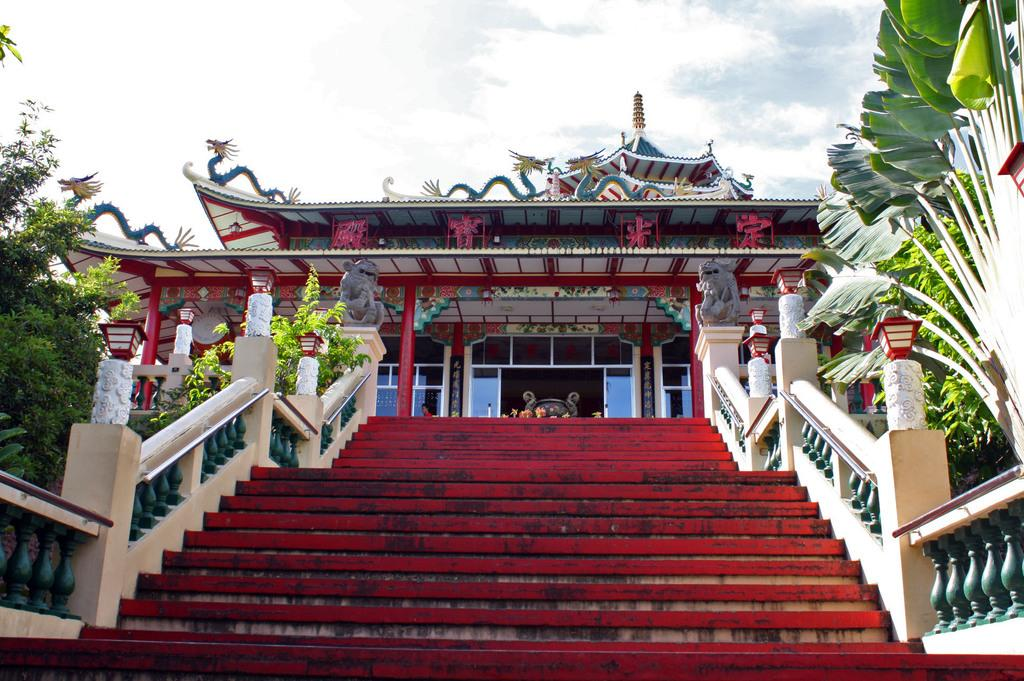What structure is present in the image? There is a staircase in the image. What feature is added to the staircase? Several lights are placed on the staircase. What can be seen in the background of the image? There is a building and a group of trees in the background of the image. What part of the natural environment is visible in the image? The sky is visible in the background of the image. What type of sofa can be seen in the image? There is no sofa present in the image. What laborers are working on the staircase in the image? There are no laborers present in the image; it only shows the staircase with lights. 